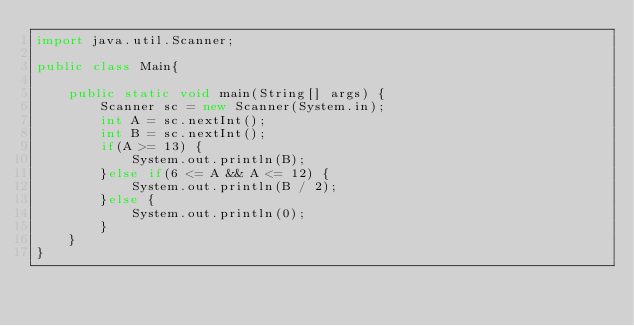<code> <loc_0><loc_0><loc_500><loc_500><_Java_>import java.util.Scanner;

public class Main{
    
    public static void main(String[] args) {
        Scanner sc = new Scanner(System.in);
        int A = sc.nextInt();
        int B = sc.nextInt();
        if(A >= 13) {
        	System.out.println(B);
        }else if(6 <= A && A <= 12) {
        	System.out.println(B / 2);
        }else {
        	System.out.println(0);
        }
    }
}</code> 